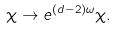<formula> <loc_0><loc_0><loc_500><loc_500>\chi \rightarrow e ^ { ( d - 2 ) \omega } \chi .</formula> 